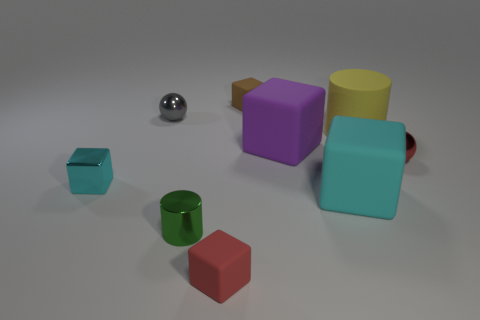What number of things are cyan things or large shiny cubes?
Offer a terse response. 2. Is there a matte cube that has the same color as the metallic block?
Provide a short and direct response. Yes. Is the number of brown cylinders less than the number of shiny cylinders?
Keep it short and to the point. Yes. How many things are small gray things or shiny spheres that are on the left side of the tiny green metallic thing?
Your answer should be very brief. 1. Is there a large cyan object that has the same material as the small brown cube?
Your response must be concise. Yes. There is a red sphere that is the same size as the red matte thing; what is its material?
Offer a terse response. Metal. The red object left of the tiny rubber object behind the small metallic block is made of what material?
Offer a very short reply. Rubber. Is the shape of the red thing left of the large purple matte cube the same as  the big cyan matte thing?
Keep it short and to the point. Yes. What color is the block that is the same material as the small green cylinder?
Provide a succinct answer. Cyan. There is a cyan cube that is to the left of the brown object; what is its material?
Give a very brief answer. Metal. 